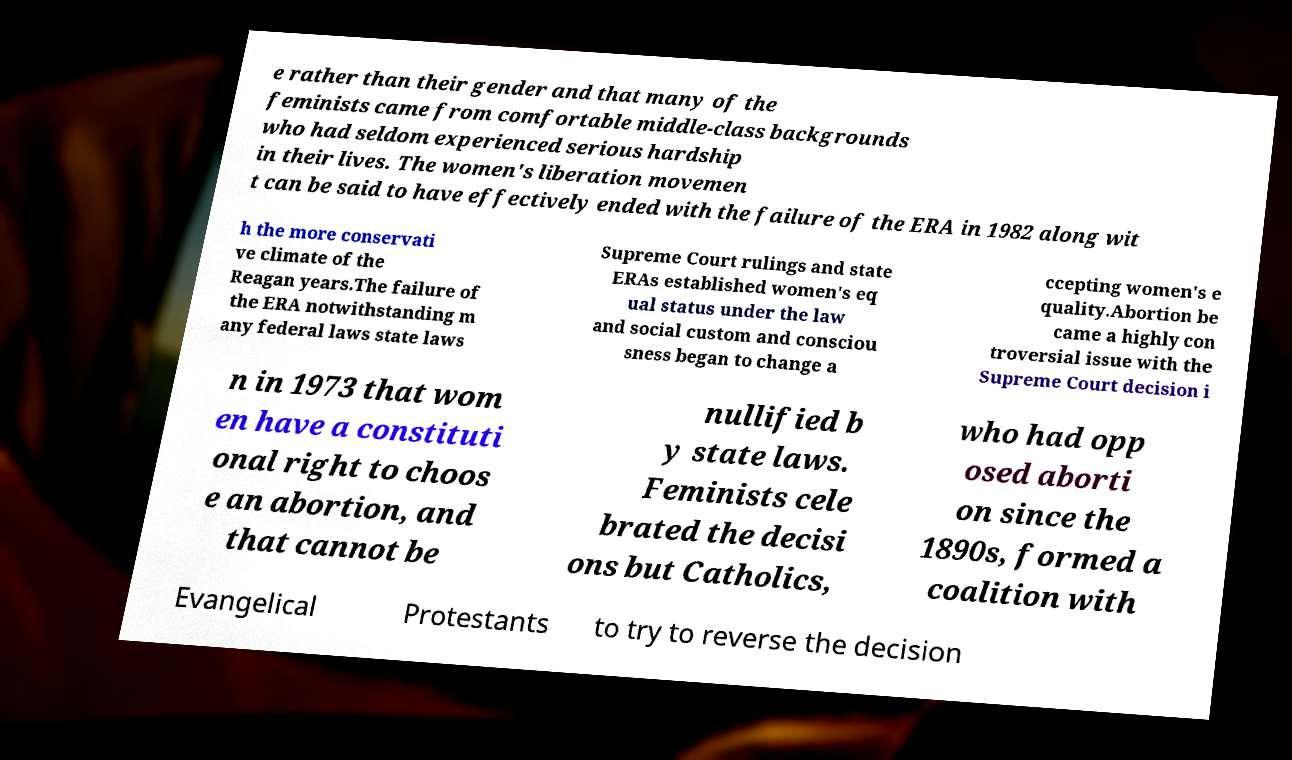Can you accurately transcribe the text from the provided image for me? e rather than their gender and that many of the feminists came from comfortable middle-class backgrounds who had seldom experienced serious hardship in their lives. The women's liberation movemen t can be said to have effectively ended with the failure of the ERA in 1982 along wit h the more conservati ve climate of the Reagan years.The failure of the ERA notwithstanding m any federal laws state laws Supreme Court rulings and state ERAs established women's eq ual status under the law and social custom and consciou sness began to change a ccepting women's e quality.Abortion be came a highly con troversial issue with the Supreme Court decision i n in 1973 that wom en have a constituti onal right to choos e an abortion, and that cannot be nullified b y state laws. Feminists cele brated the decisi ons but Catholics, who had opp osed aborti on since the 1890s, formed a coalition with Evangelical Protestants to try to reverse the decision 